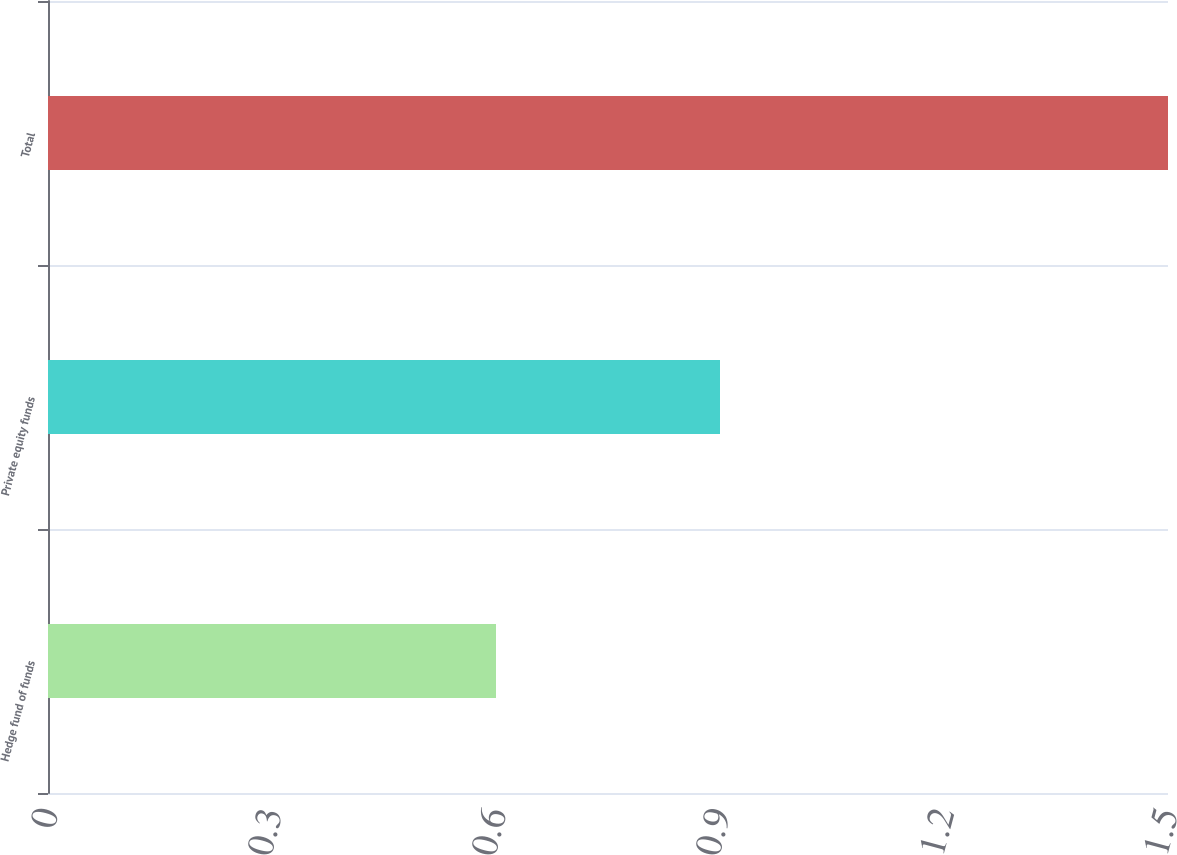<chart> <loc_0><loc_0><loc_500><loc_500><bar_chart><fcel>Hedge fund of funds<fcel>Private equity funds<fcel>Total<nl><fcel>0.6<fcel>0.9<fcel>1.5<nl></chart> 